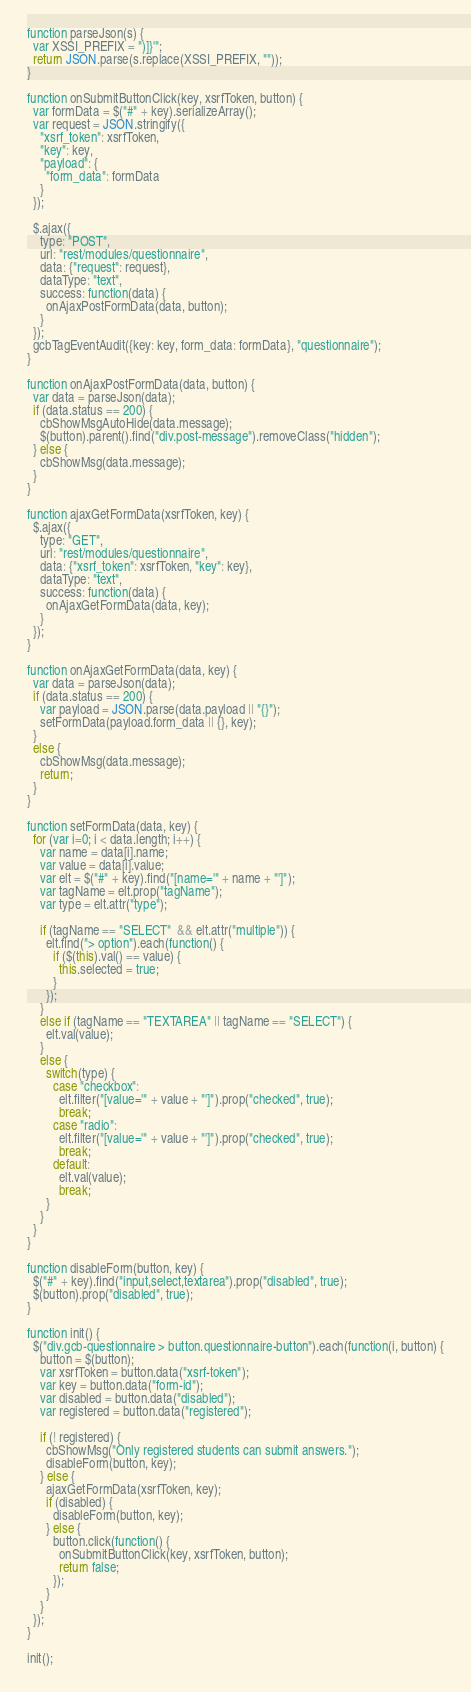Convert code to text. <code><loc_0><loc_0><loc_500><loc_500><_JavaScript_>function parseJson(s) {
  var XSSI_PREFIX = ")]}'";
  return JSON.parse(s.replace(XSSI_PREFIX, ""));
}

function onSubmitButtonClick(key, xsrfToken, button) {
  var formData = $("#" + key).serializeArray();
  var request = JSON.stringify({
    "xsrf_token": xsrfToken,
    "key": key,
    "payload": {
      "form_data": formData
    }
  });

  $.ajax({
    type: "POST",
    url: "rest/modules/questionnaire",
    data: {"request": request},
    dataType: "text",
    success: function(data) {
      onAjaxPostFormData(data, button);
    }
  });
  gcbTagEventAudit({key: key, form_data: formData}, "questionnaire");
}

function onAjaxPostFormData(data, button) {
  var data = parseJson(data);
  if (data.status == 200) {
    cbShowMsgAutoHide(data.message);
    $(button).parent().find("div.post-message").removeClass("hidden");
  } else {
    cbShowMsg(data.message);
  }
}

function ajaxGetFormData(xsrfToken, key) {
  $.ajax({
    type: "GET",
    url: "rest/modules/questionnaire",
    data: {"xsrf_token": xsrfToken, "key": key},
    dataType: "text",
    success: function(data) {
      onAjaxGetFormData(data, key);
    }
  });
}

function onAjaxGetFormData(data, key) {
  var data = parseJson(data);
  if (data.status == 200) {
    var payload = JSON.parse(data.payload || "{}");
    setFormData(payload.form_data || {}, key);
  }
  else {
    cbShowMsg(data.message);
    return;
  }
}

function setFormData(data, key) {
  for (var i=0; i < data.length; i++) {
    var name = data[i].name;
    var value = data[i].value;
    var elt = $("#" + key).find("[name='" + name + "']");
    var tagName = elt.prop("tagName");
    var type = elt.attr("type");

    if (tagName == "SELECT"  && elt.attr("multiple")) {
      elt.find("> option").each(function() {
        if ($(this).val() == value) {
          this.selected = true;
        }
      });
    }
    else if (tagName == "TEXTAREA" || tagName == "SELECT") {
      elt.val(value);
    }
    else {
      switch(type) {
        case "checkbox":
          elt.filter("[value='" + value + "']").prop("checked", true);
          break;
        case "radio":
          elt.filter("[value='" + value + "']").prop("checked", true);
          break;
        default:
          elt.val(value);
          break;
      }
    }
  }
}

function disableForm(button, key) {
  $("#" + key).find("input,select,textarea").prop("disabled", true);
  $(button).prop("disabled", true);
}

function init() {
  $("div.gcb-questionnaire > button.questionnaire-button").each(function(i, button) {
    button = $(button);
    var xsrfToken = button.data("xsrf-token");
    var key = button.data("form-id");
    var disabled = button.data("disabled");
    var registered = button.data("registered");

    if (! registered) {
      cbShowMsg("Only registered students can submit answers.");
      disableForm(button, key);
    } else {
      ajaxGetFormData(xsrfToken, key);
      if (disabled) {
        disableForm(button, key);
      } else {
        button.click(function() {
          onSubmitButtonClick(key, xsrfToken, button);
          return false;
        });
      }
    }
  });
}

init();
</code> 